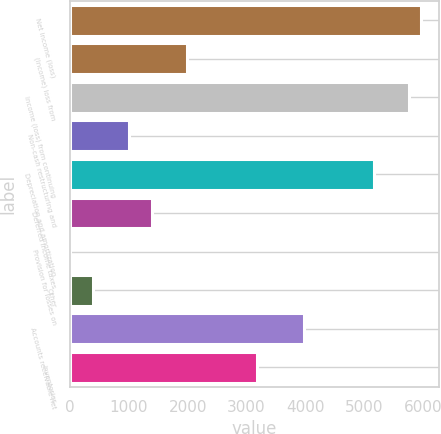Convert chart to OTSL. <chart><loc_0><loc_0><loc_500><loc_500><bar_chart><fcel>Net income (loss)<fcel>(Income) loss from<fcel>Income (loss) from continuing<fcel>Non-cash restructuring and<fcel>Depreciation and amortization<fcel>Deferred income taxes<fcel>Provision for losses on<fcel>Other<fcel>Accounts receivable net<fcel>Inventories<nl><fcel>5962<fcel>1990<fcel>5763.4<fcel>997<fcel>5167.6<fcel>1394.2<fcel>4<fcel>401.2<fcel>3976<fcel>3181.6<nl></chart> 